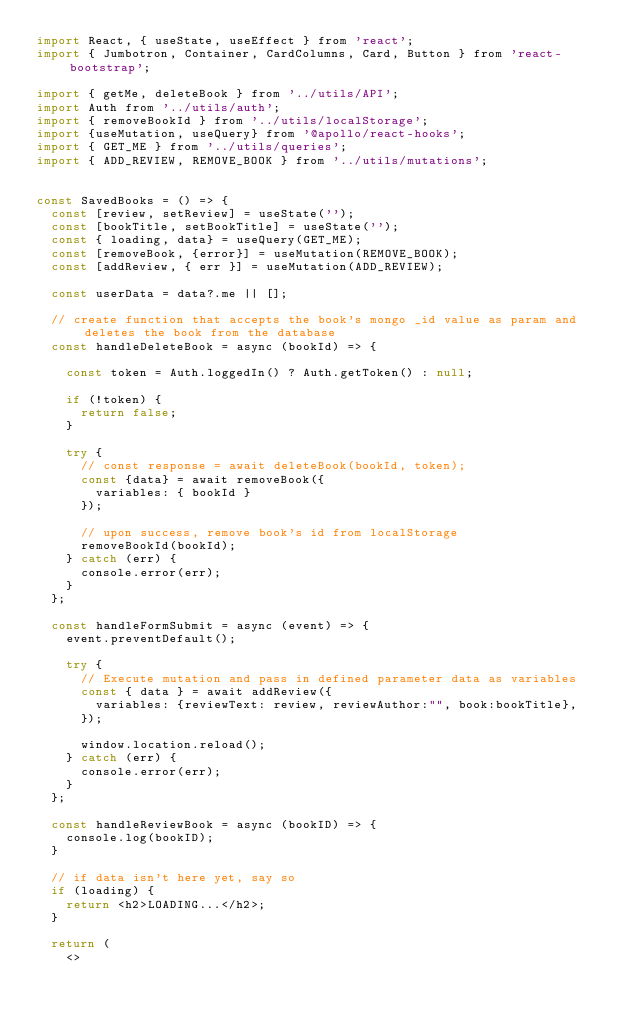<code> <loc_0><loc_0><loc_500><loc_500><_JavaScript_>import React, { useState, useEffect } from 'react';
import { Jumbotron, Container, CardColumns, Card, Button } from 'react-bootstrap';

import { getMe, deleteBook } from '../utils/API';
import Auth from '../utils/auth';
import { removeBookId } from '../utils/localStorage';
import {useMutation, useQuery} from '@apollo/react-hooks';
import { GET_ME } from '../utils/queries';
import { ADD_REVIEW, REMOVE_BOOK } from '../utils/mutations';


const SavedBooks = () => {
  const [review, setReview] = useState('');
  const [bookTitle, setBookTitle] = useState('');
  const { loading, data} = useQuery(GET_ME);
  const [removeBook, {error}] = useMutation(REMOVE_BOOK);
  const [addReview, { err }] = useMutation(ADD_REVIEW);

  const userData = data?.me || [];

  // create function that accepts the book's mongo _id value as param and deletes the book from the database
  const handleDeleteBook = async (bookId) => {

    const token = Auth.loggedIn() ? Auth.getToken() : null;

    if (!token) {
      return false;
    }

    try {
      // const response = await deleteBook(bookId, token);
      const {data} = await removeBook({
        variables: { bookId }
      });

      // upon success, remove book's id from localStorage
      removeBookId(bookId);
    } catch (err) {
      console.error(err);
    }
  };

  const handleFormSubmit = async (event) => {
    event.preventDefault();

    try {
      // Execute mutation and pass in defined parameter data as variables
      const { data } = await addReview({
        variables: {reviewText: review, reviewAuthor:"", book:bookTitle},
      });

      window.location.reload();
    } catch (err) {
      console.error(err);
    }
  };

  const handleReviewBook = async (bookID) => {
    console.log(bookID);    
  }

  // if data isn't here yet, say so
  if (loading) {
    return <h2>LOADING...</h2>;
  }

  return (
    <></code> 